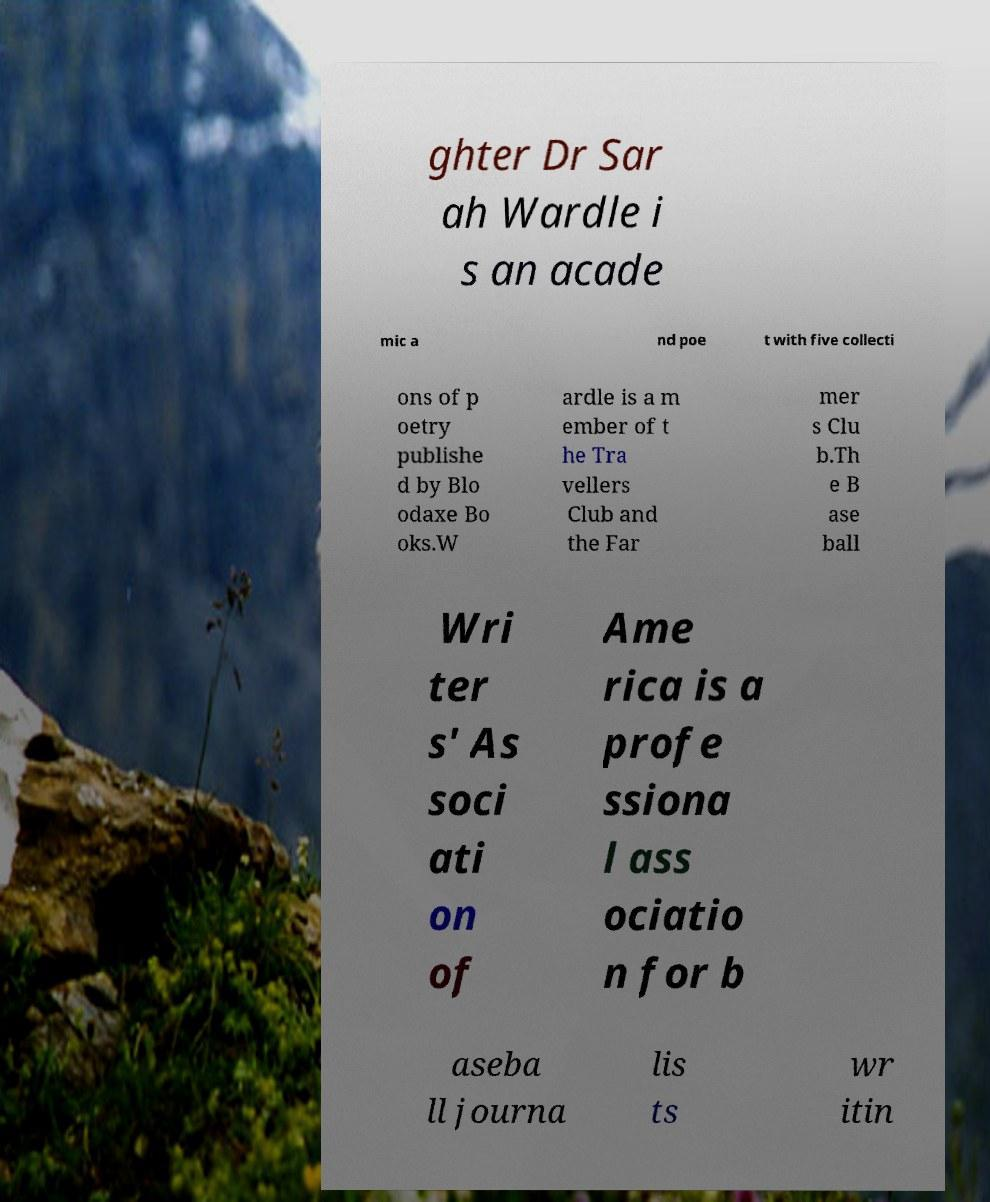I need the written content from this picture converted into text. Can you do that? ghter Dr Sar ah Wardle i s an acade mic a nd poe t with five collecti ons of p oetry publishe d by Blo odaxe Bo oks.W ardle is a m ember of t he Tra vellers Club and the Far mer s Clu b.Th e B ase ball Wri ter s' As soci ati on of Ame rica is a profe ssiona l ass ociatio n for b aseba ll journa lis ts wr itin 